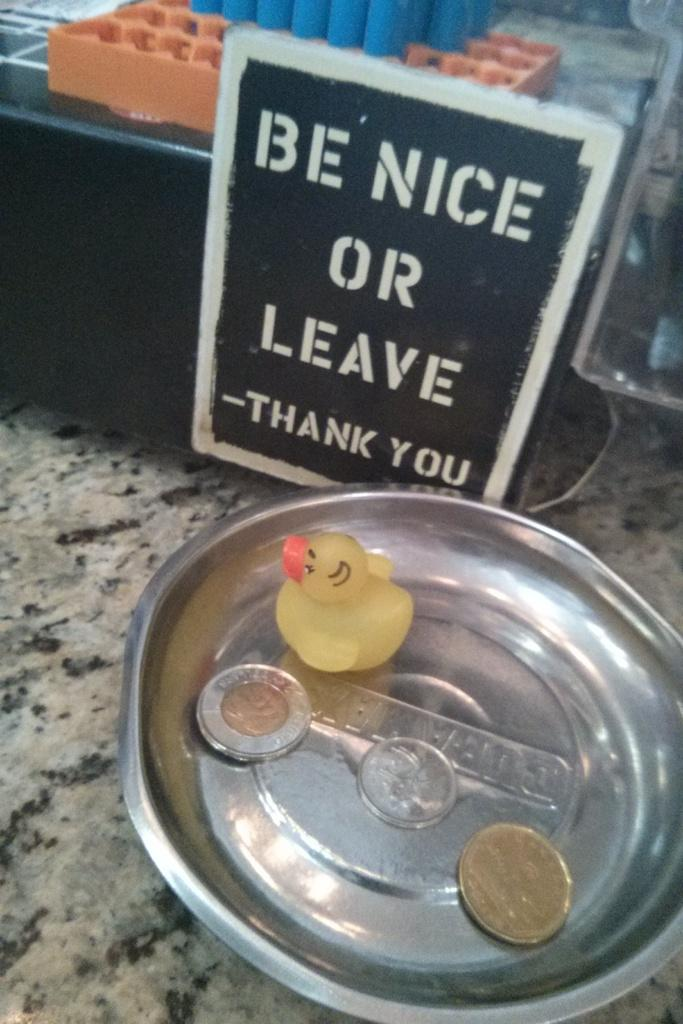What can be seen in the image that is not related to food or money? There is a toy in the image that is not related to food or money. What items are related to money in the image? There are coins on a plate in the image that are related to money. What can be seen in the background of the image? There are objects visible in the background of the image, including a board. What is written on the board in the background? There is text on the board in the background. What type of flooring is visible at the bottom of the image? The bottom of the image appears to have a tile. What type of cream can be seen dripping from the toy in the image? There is no cream present in the image, and the toy is not depicted as having any cream on it. What type of fork is used to eat the coins on the plate in the image? There are no forks present in the image, and coins are not typically eaten with a fork. 